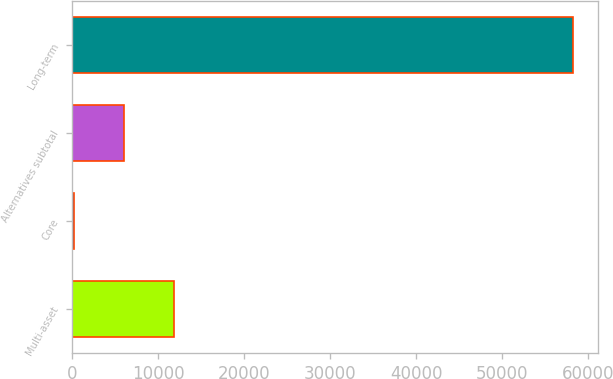<chart> <loc_0><loc_0><loc_500><loc_500><bar_chart><fcel>Multi-asset<fcel>Core<fcel>Alternatives subtotal<fcel>Long-term<nl><fcel>11815<fcel>213<fcel>6014<fcel>58223<nl></chart> 